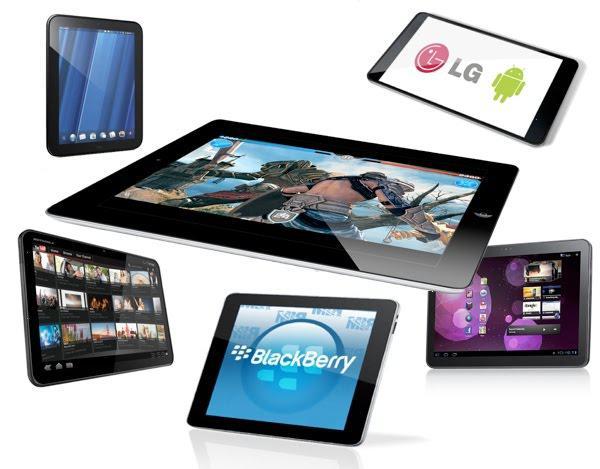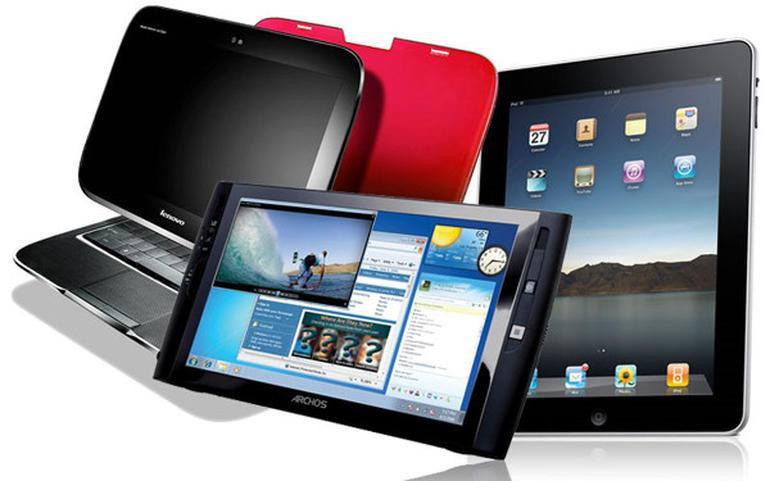The first image is the image on the left, the second image is the image on the right. Given the left and right images, does the statement "The right image includes a greater number of devices than the left image." hold true? Answer yes or no. No. 